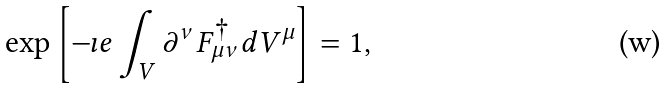Convert formula to latex. <formula><loc_0><loc_0><loc_500><loc_500>\exp \left [ - \imath e \int _ { V } \partial ^ { \nu } F _ { \mu \nu } ^ { \dagger } d V ^ { \mu } \right ] = 1 ,</formula> 